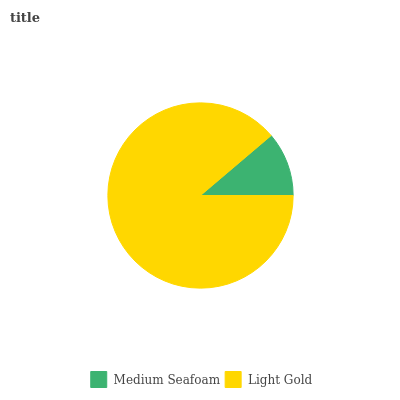Is Medium Seafoam the minimum?
Answer yes or no. Yes. Is Light Gold the maximum?
Answer yes or no. Yes. Is Light Gold the minimum?
Answer yes or no. No. Is Light Gold greater than Medium Seafoam?
Answer yes or no. Yes. Is Medium Seafoam less than Light Gold?
Answer yes or no. Yes. Is Medium Seafoam greater than Light Gold?
Answer yes or no. No. Is Light Gold less than Medium Seafoam?
Answer yes or no. No. Is Light Gold the high median?
Answer yes or no. Yes. Is Medium Seafoam the low median?
Answer yes or no. Yes. Is Medium Seafoam the high median?
Answer yes or no. No. Is Light Gold the low median?
Answer yes or no. No. 